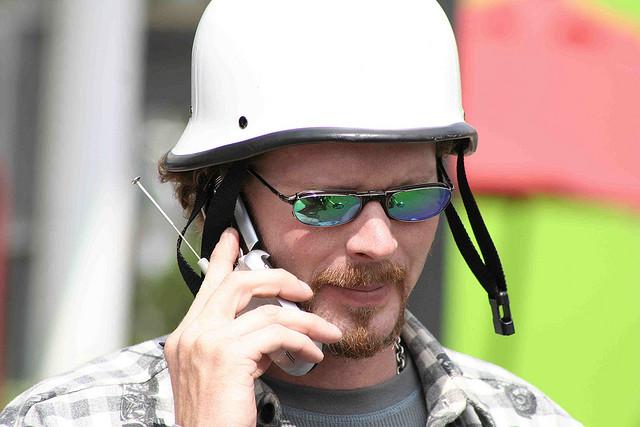What color is the man's helmet?
Be succinct. White. Is the man a construction worker?
Give a very brief answer. Yes. Is the mobile phone a flip phone?
Be succinct. Yes. 